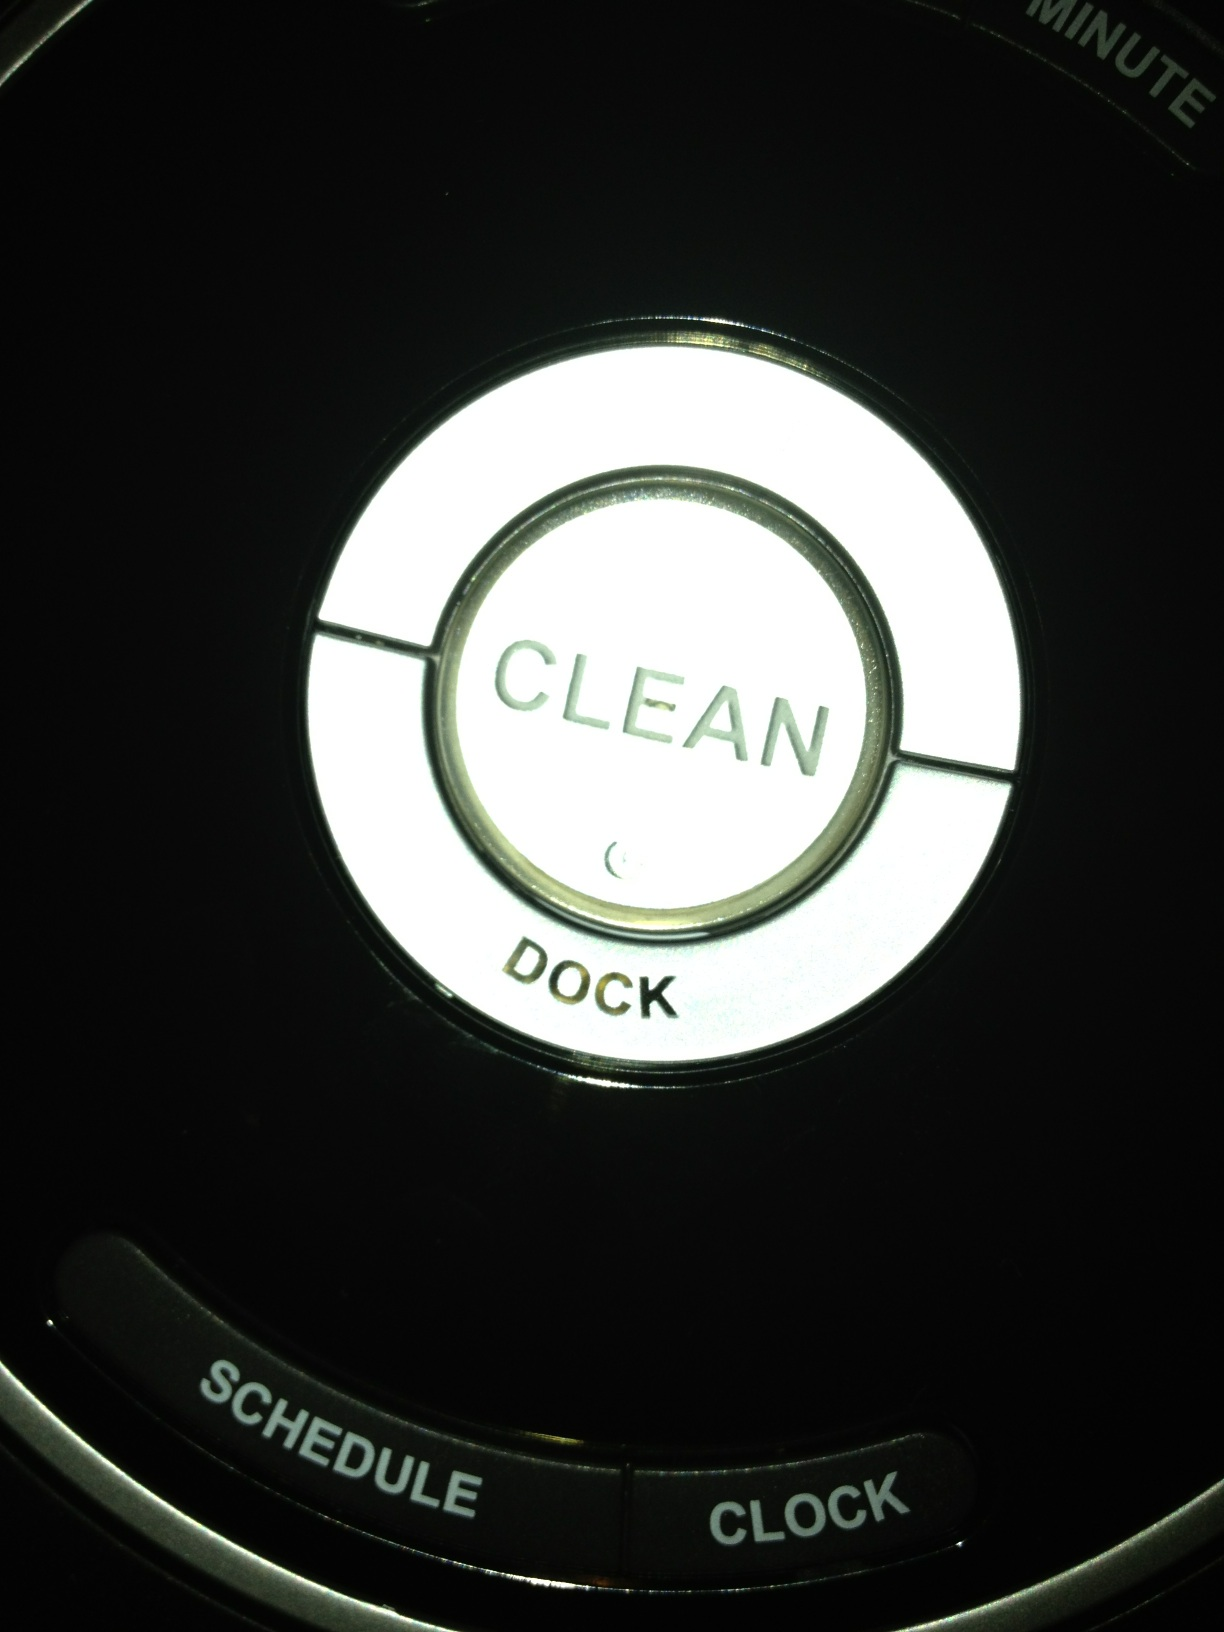What does the 'minute' label next to the top button imply about its function? The 'minute' label near the 'CLEAN' button suggests that this button might also control timing functions, potentially allowing users to set a timer for how long the cleaning should last. 